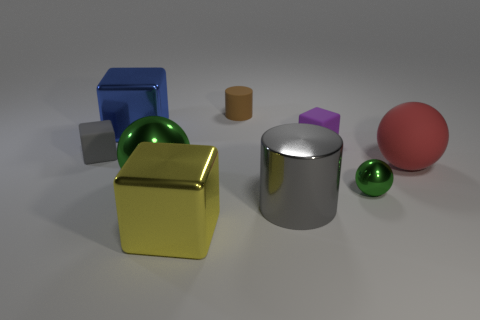The large object that is on the left side of the green metallic thing to the left of the big metallic cube in front of the blue shiny block is what shape? The large object situated to the left of the green metallic sphere, itself located to the left of the large metallic cube, and in front of the blue shiny block, is a yellow cube with a slightly reflective surface. 